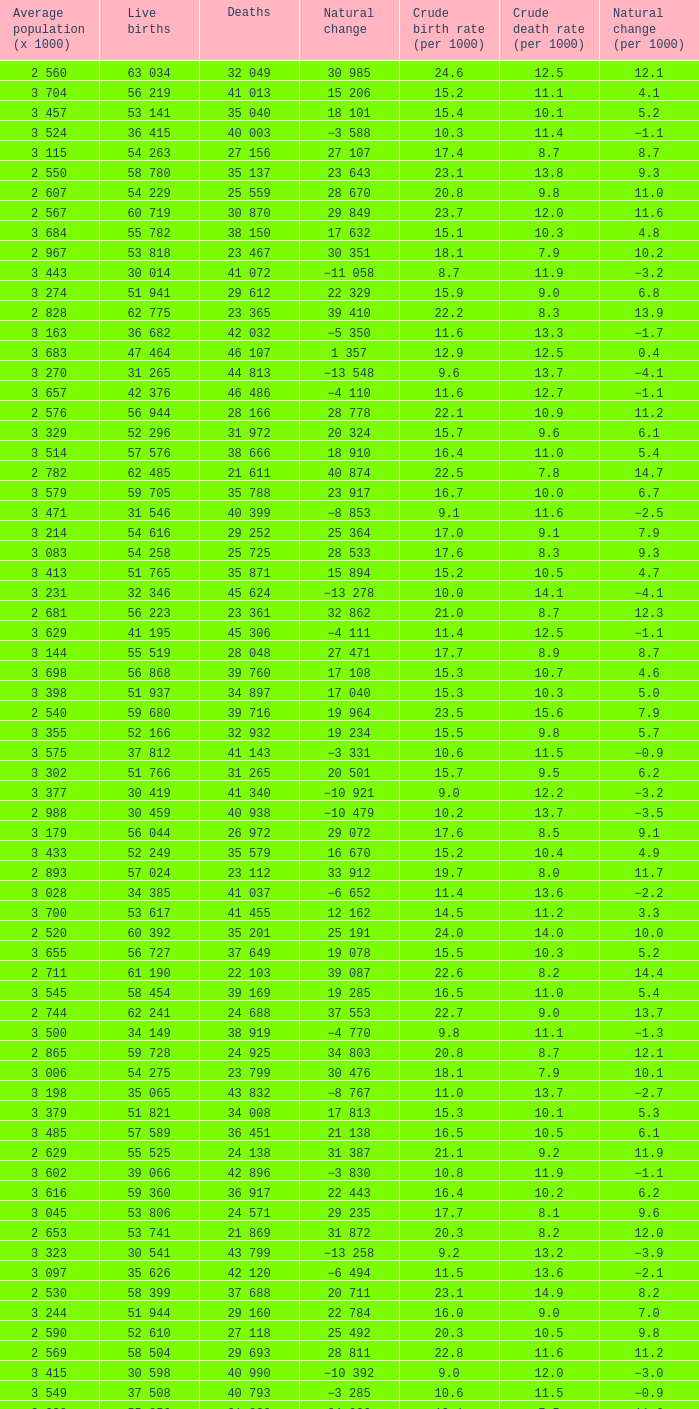Which Average population (x 1000) has a Crude death rate (per 1000) smaller than 10.9, and a Crude birth rate (per 1000) smaller than 19.7, and a Natural change (per 1000) of 8.7, and Live births of 54 263? 3 115. 